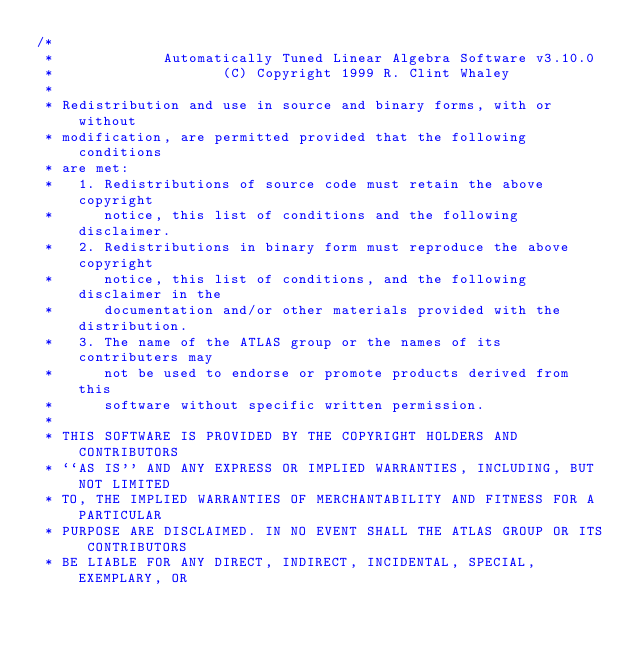<code> <loc_0><loc_0><loc_500><loc_500><_C_>/*
 *             Automatically Tuned Linear Algebra Software v3.10.0
 *                    (C) Copyright 1999 R. Clint Whaley
 *
 * Redistribution and use in source and binary forms, with or without
 * modification, are permitted provided that the following conditions
 * are met:
 *   1. Redistributions of source code must retain the above copyright
 *      notice, this list of conditions and the following disclaimer.
 *   2. Redistributions in binary form must reproduce the above copyright
 *      notice, this list of conditions, and the following disclaimer in the
 *      documentation and/or other materials provided with the distribution.
 *   3. The name of the ATLAS group or the names of its contributers may
 *      not be used to endorse or promote products derived from this
 *      software without specific written permission.
 *
 * THIS SOFTWARE IS PROVIDED BY THE COPYRIGHT HOLDERS AND CONTRIBUTORS
 * ``AS IS'' AND ANY EXPRESS OR IMPLIED WARRANTIES, INCLUDING, BUT NOT LIMITED
 * TO, THE IMPLIED WARRANTIES OF MERCHANTABILITY AND FITNESS FOR A PARTICULAR
 * PURPOSE ARE DISCLAIMED. IN NO EVENT SHALL THE ATLAS GROUP OR ITS CONTRIBUTORS
 * BE LIABLE FOR ANY DIRECT, INDIRECT, INCIDENTAL, SPECIAL, EXEMPLARY, OR</code> 